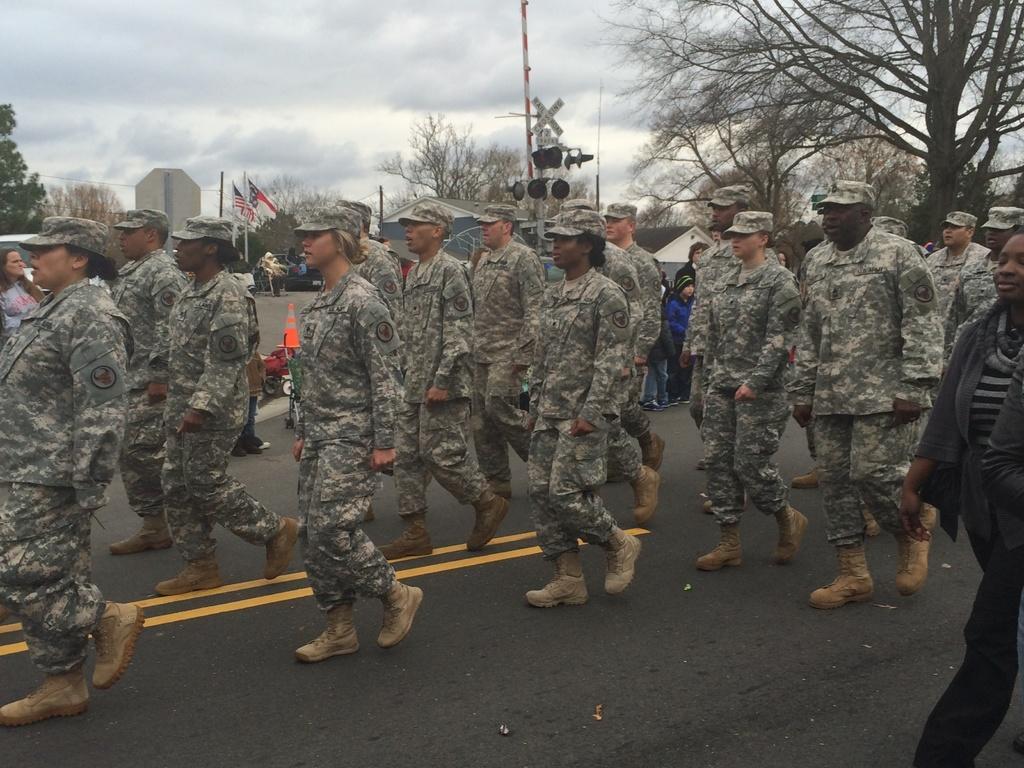In one or two sentences, can you explain what this image depicts? In this image we can see these people wearing uniform, caps and shoes are walking on the road. In the background, we can see a few more people standing on the road, we can see road cones, traffic signal poles, trees, flags, houses, boards and the cloudy sky in the background. 